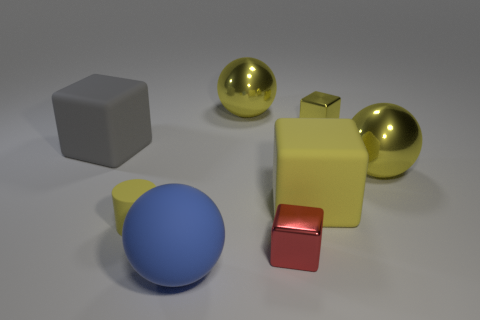Add 2 large yellow matte things. How many objects exist? 10 Subtract all shiny spheres. How many spheres are left? 1 Subtract 1 spheres. How many spheres are left? 2 Subtract all yellow spheres. How many spheres are left? 1 Subtract all small red metal blocks. Subtract all yellow metal balls. How many objects are left? 5 Add 8 big gray things. How many big gray things are left? 9 Add 4 metal cylinders. How many metal cylinders exist? 4 Subtract 0 blue cylinders. How many objects are left? 8 Subtract all cylinders. How many objects are left? 7 Subtract all green blocks. Subtract all gray cylinders. How many blocks are left? 4 